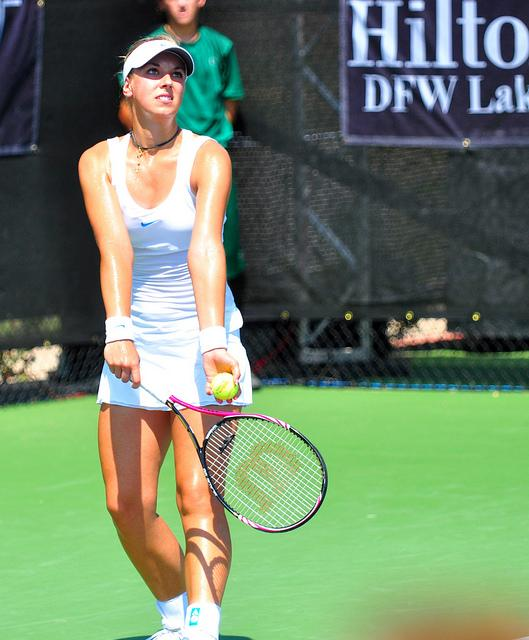Why is she holding the ball? Please explain your reasoning. will serve. Holding and throwing the ball up at the beginning of the match is to hit it over the net; this is called 'serving'. 